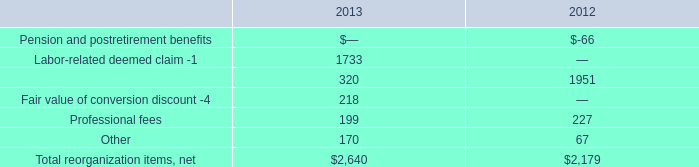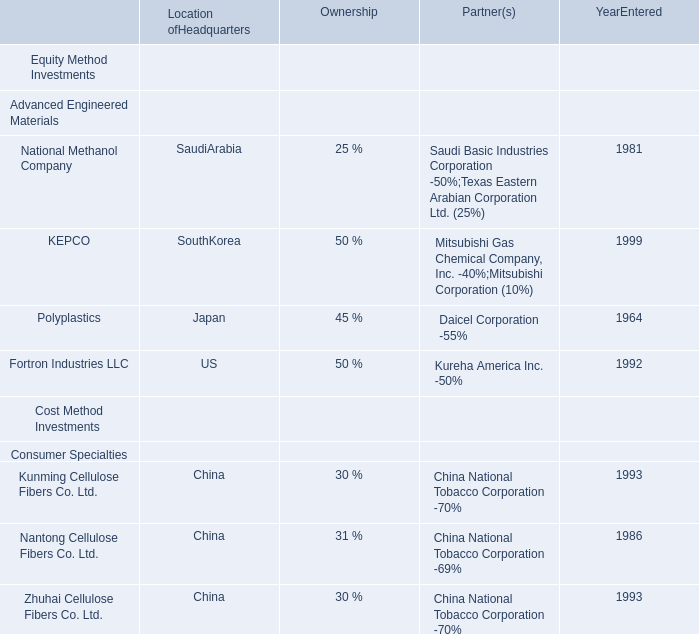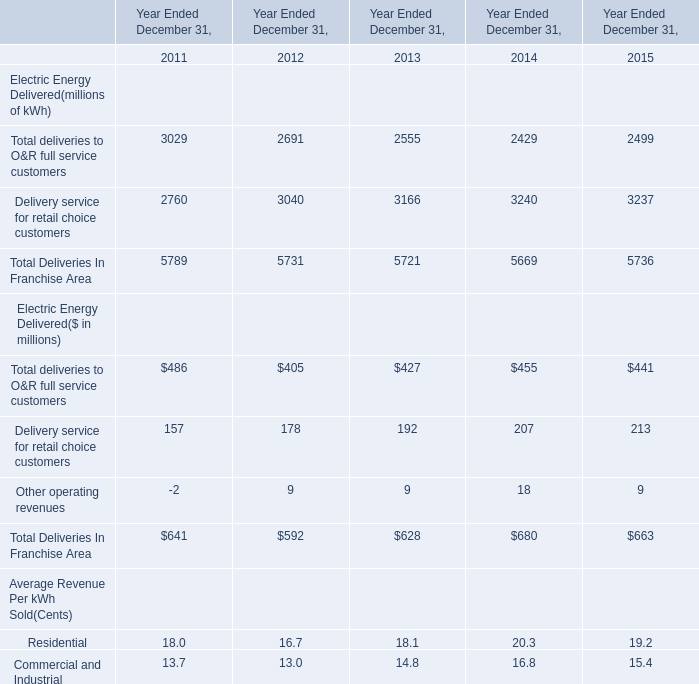by how much did aircraft and facility financing renegotiations and rejections decrease from 2012 to 2013? 
Computations: ((320 - 1951) / 1951)
Answer: -0.83598. 